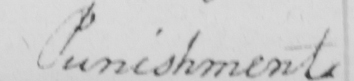What is written in this line of handwriting? Punishment 